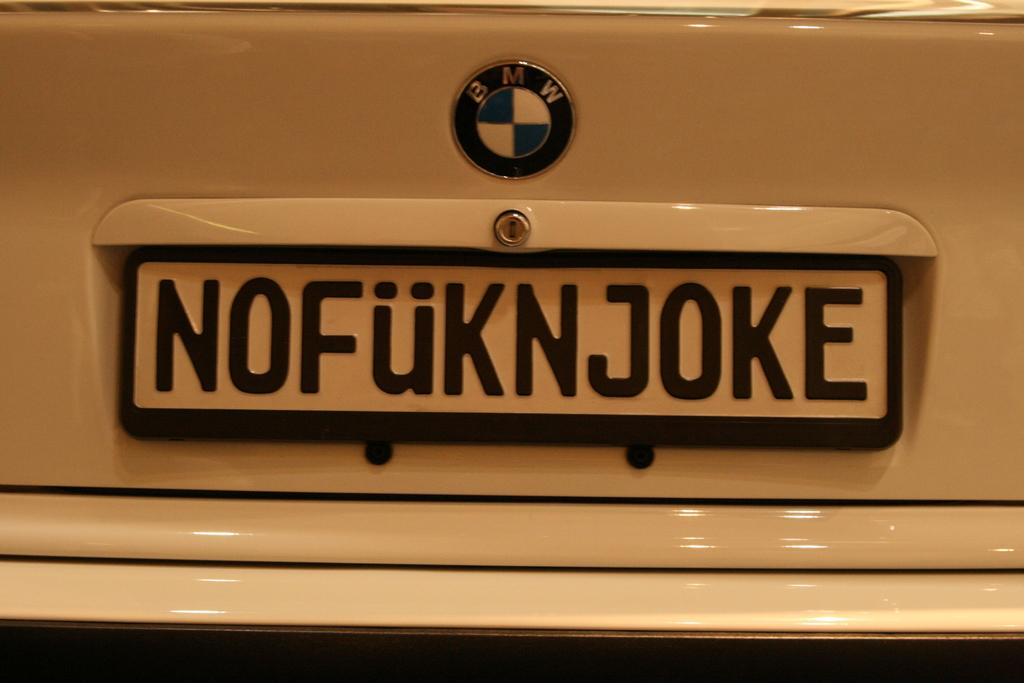<image>
Relay a brief, clear account of the picture shown. The licence plate of a BMW that says NOFUKNJOKE 